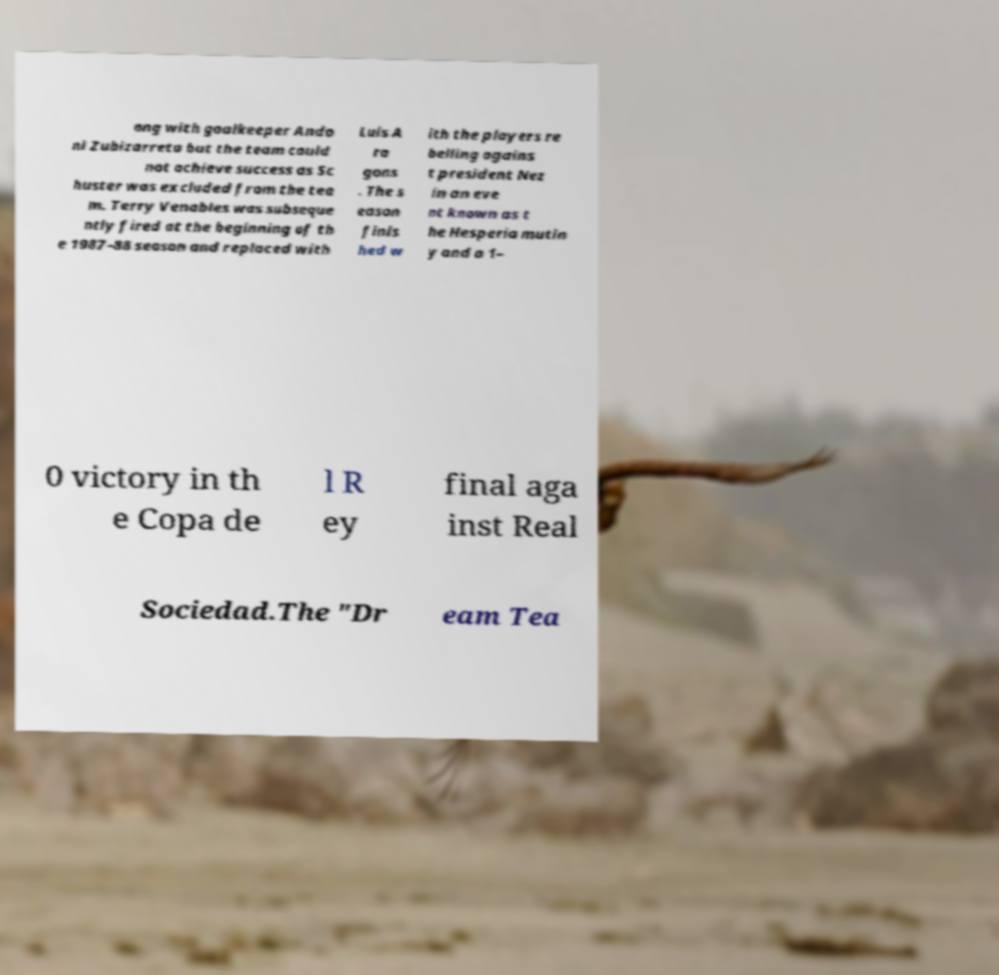Can you accurately transcribe the text from the provided image for me? ong with goalkeeper Ando ni Zubizarreta but the team could not achieve success as Sc huster was excluded from the tea m. Terry Venables was subseque ntly fired at the beginning of th e 1987–88 season and replaced with Luis A ra gons . The s eason finis hed w ith the players re belling agains t president Nez in an eve nt known as t he Hesperia mutin y and a 1– 0 victory in th e Copa de l R ey final aga inst Real Sociedad.The "Dr eam Tea 